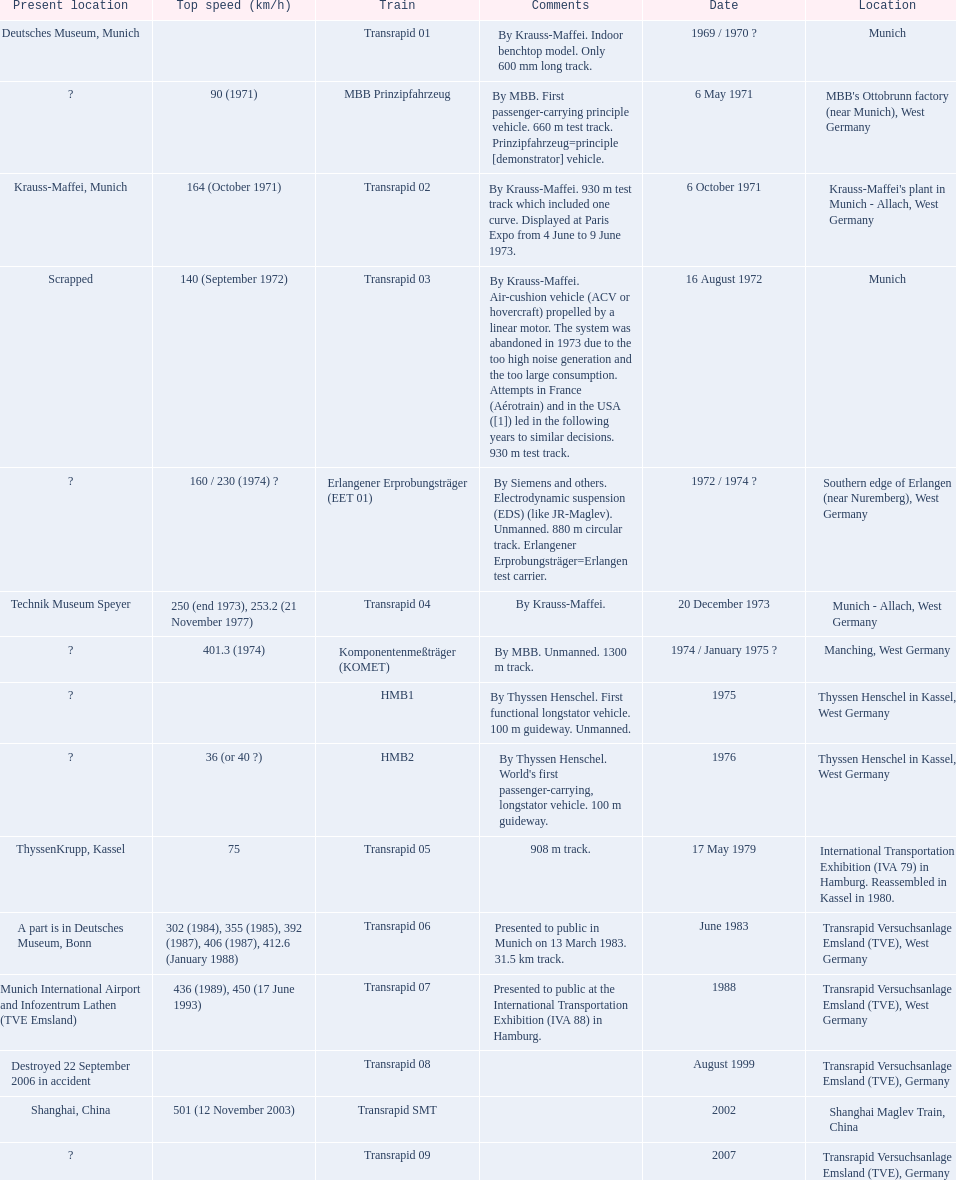What is the top speed reached by any trains shown here? 501 (12 November 2003). What train has reached a top speed of 501? Transrapid SMT. 